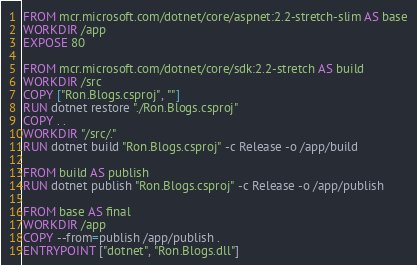Convert code to text. <code><loc_0><loc_0><loc_500><loc_500><_Dockerfile_>FROM mcr.microsoft.com/dotnet/core/aspnet:2.2-stretch-slim AS base
WORKDIR /app
EXPOSE 80

FROM mcr.microsoft.com/dotnet/core/sdk:2.2-stretch AS build
WORKDIR /src
COPY ["Ron.Blogs.csproj", ""]
RUN dotnet restore "./Ron.Blogs.csproj"
COPY . .
WORKDIR "/src/."
RUN dotnet build "Ron.Blogs.csproj" -c Release -o /app/build

FROM build AS publish
RUN dotnet publish "Ron.Blogs.csproj" -c Release -o /app/publish

FROM base AS final
WORKDIR /app
COPY --from=publish /app/publish .
ENTRYPOINT ["dotnet", "Ron.Blogs.dll"]
</code> 